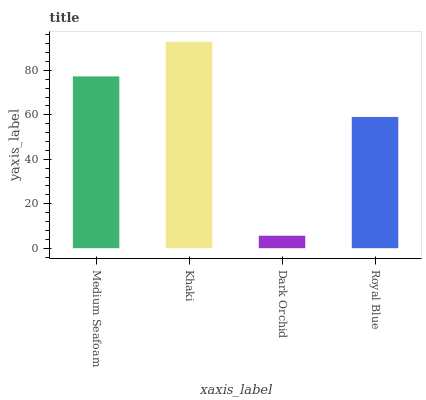Is Dark Orchid the minimum?
Answer yes or no. Yes. Is Khaki the maximum?
Answer yes or no. Yes. Is Khaki the minimum?
Answer yes or no. No. Is Dark Orchid the maximum?
Answer yes or no. No. Is Khaki greater than Dark Orchid?
Answer yes or no. Yes. Is Dark Orchid less than Khaki?
Answer yes or no. Yes. Is Dark Orchid greater than Khaki?
Answer yes or no. No. Is Khaki less than Dark Orchid?
Answer yes or no. No. Is Medium Seafoam the high median?
Answer yes or no. Yes. Is Royal Blue the low median?
Answer yes or no. Yes. Is Khaki the high median?
Answer yes or no. No. Is Dark Orchid the low median?
Answer yes or no. No. 